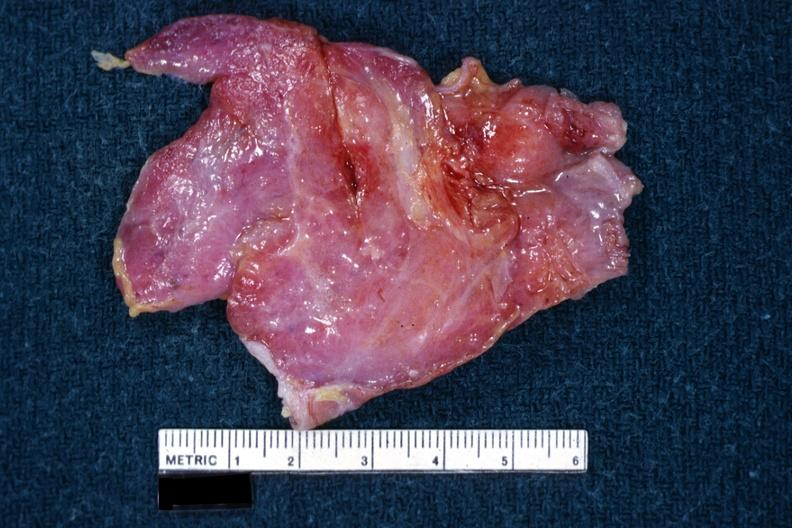what does this image show?
Answer the question using a single word or phrase. I am not sure of diagnosis 